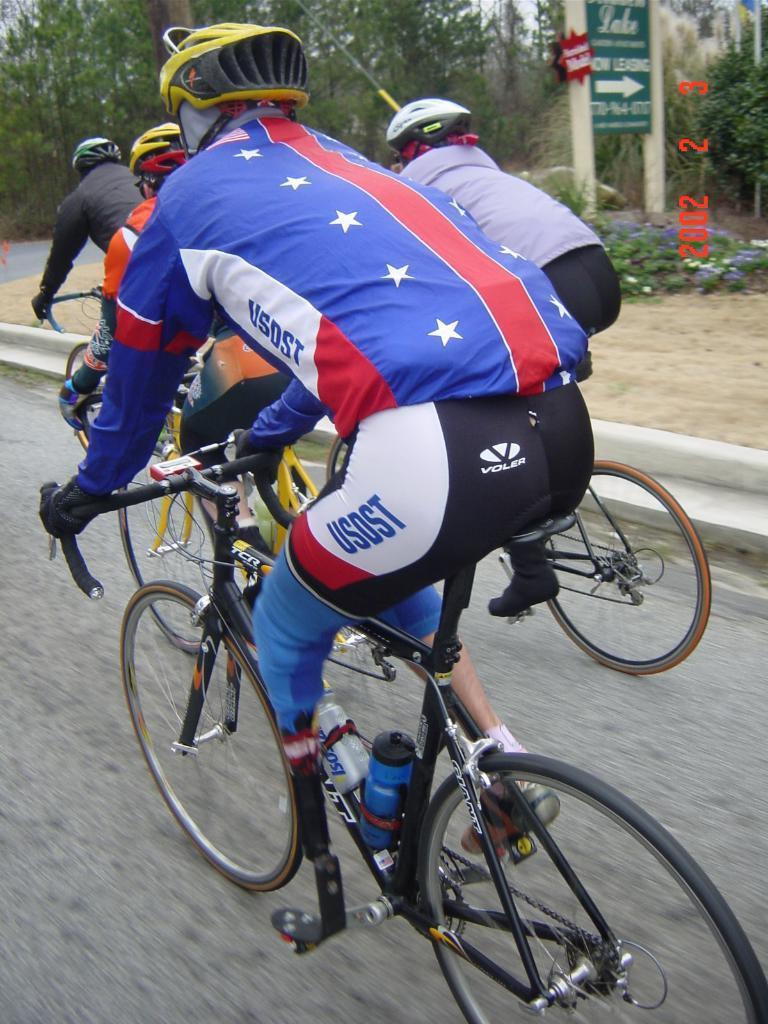How would you summarize this image in a sentence or two? In this image we can see people riding bicycles. In the background there are trees. We can see a board. At the bottom there is a road. 